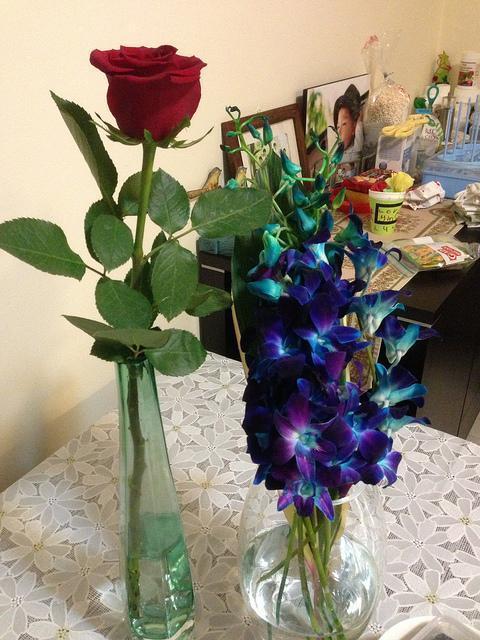How many potted plants are in the photo?
Give a very brief answer. 2. How many vases are there?
Give a very brief answer. 2. 